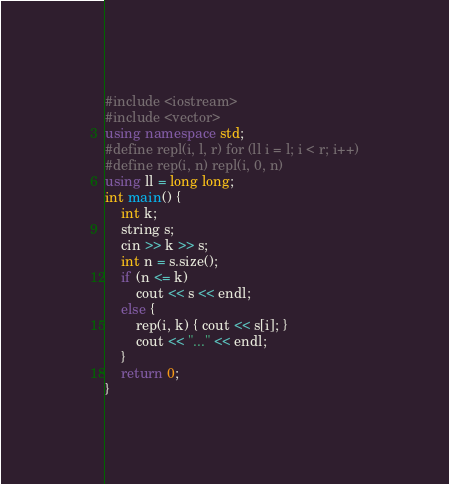<code> <loc_0><loc_0><loc_500><loc_500><_C++_>#include <iostream>
#include <vector>
using namespace std;
#define repl(i, l, r) for (ll i = l; i < r; i++)
#define rep(i, n) repl(i, 0, n)
using ll = long long;
int main() {
	int k;
	string s;
	cin >> k >> s;
	int n = s.size();
	if (n <= k)
		cout << s << endl;
	else {
		rep(i, k) { cout << s[i]; }
		cout << "..." << endl;
	}
	return 0;
}</code> 